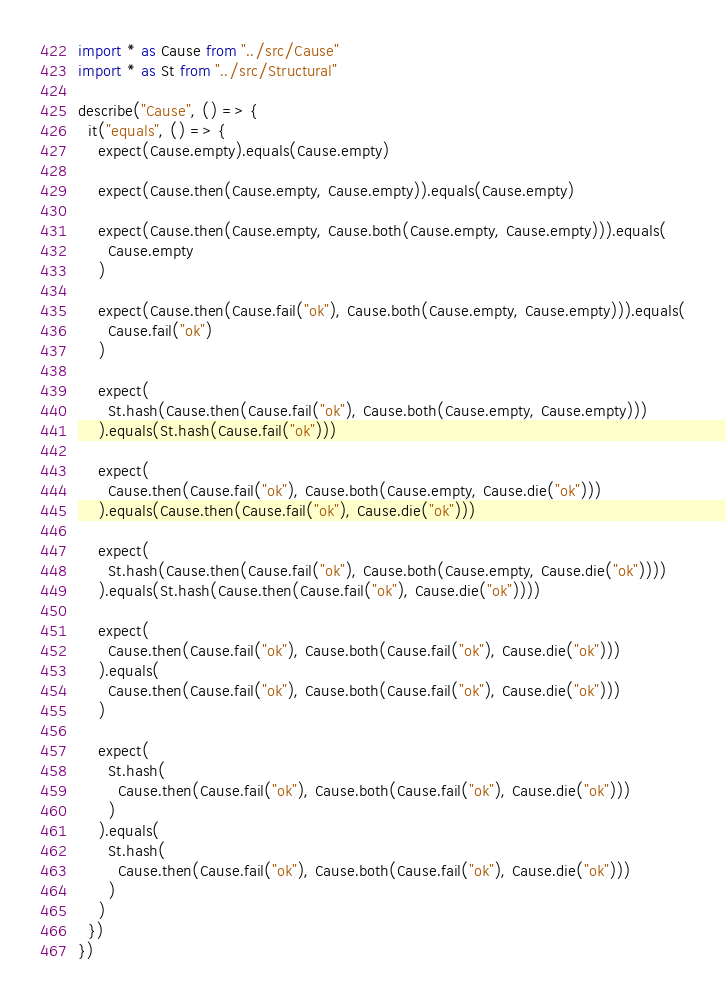<code> <loc_0><loc_0><loc_500><loc_500><_TypeScript_>import * as Cause from "../src/Cause"
import * as St from "../src/Structural"

describe("Cause", () => {
  it("equals", () => {
    expect(Cause.empty).equals(Cause.empty)

    expect(Cause.then(Cause.empty, Cause.empty)).equals(Cause.empty)

    expect(Cause.then(Cause.empty, Cause.both(Cause.empty, Cause.empty))).equals(
      Cause.empty
    )

    expect(Cause.then(Cause.fail("ok"), Cause.both(Cause.empty, Cause.empty))).equals(
      Cause.fail("ok")
    )

    expect(
      St.hash(Cause.then(Cause.fail("ok"), Cause.both(Cause.empty, Cause.empty)))
    ).equals(St.hash(Cause.fail("ok")))

    expect(
      Cause.then(Cause.fail("ok"), Cause.both(Cause.empty, Cause.die("ok")))
    ).equals(Cause.then(Cause.fail("ok"), Cause.die("ok")))

    expect(
      St.hash(Cause.then(Cause.fail("ok"), Cause.both(Cause.empty, Cause.die("ok"))))
    ).equals(St.hash(Cause.then(Cause.fail("ok"), Cause.die("ok"))))

    expect(
      Cause.then(Cause.fail("ok"), Cause.both(Cause.fail("ok"), Cause.die("ok")))
    ).equals(
      Cause.then(Cause.fail("ok"), Cause.both(Cause.fail("ok"), Cause.die("ok")))
    )

    expect(
      St.hash(
        Cause.then(Cause.fail("ok"), Cause.both(Cause.fail("ok"), Cause.die("ok")))
      )
    ).equals(
      St.hash(
        Cause.then(Cause.fail("ok"), Cause.both(Cause.fail("ok"), Cause.die("ok")))
      )
    )
  })
})
</code> 